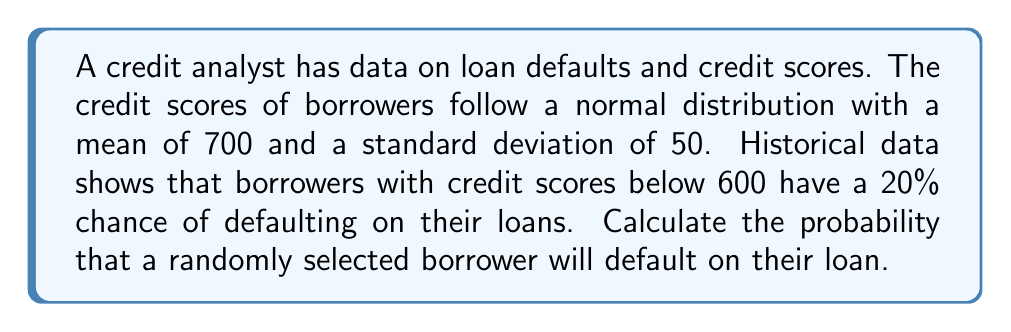Could you help me with this problem? To solve this problem, we need to follow these steps:

1. Standardize the credit score threshold:
   The threshold is 600, so we need to calculate the z-score:
   $$z = \frac{x - \mu}{\sigma} = \frac{600 - 700}{50} = -2$$

2. Find the probability of a credit score below 600:
   Using the standard normal distribution table or a calculator, we can find:
   $$P(Z < -2) = 0.0228$$

3. Calculate the probability of default:
   We know that 20% of borrowers with scores below 600 default, so:
   $$P(\text{Default}) = P(\text{Score} < 600) \times P(\text{Default} | \text{Score} < 600)$$
   $$P(\text{Default}) = 0.0228 \times 0.20 = 0.00456$$

4. Convert to percentage:
   $$0.00456 \times 100\% = 0.456\%$$
Answer: 0.456% 